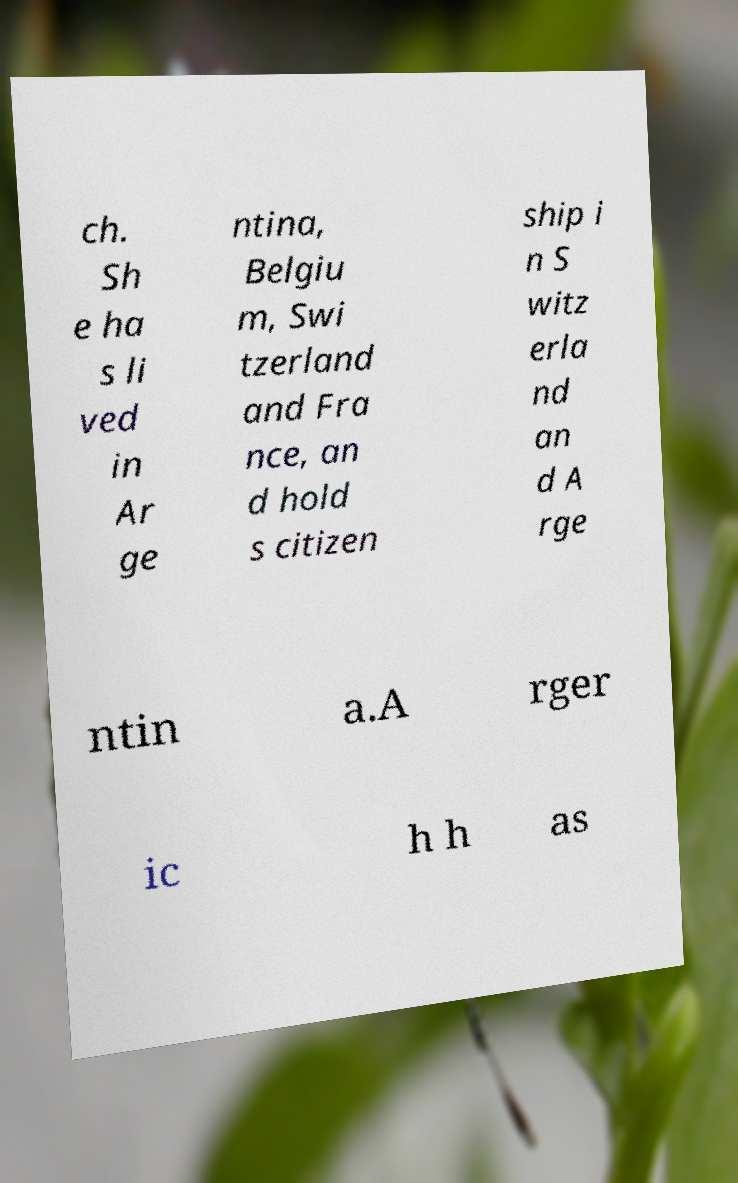For documentation purposes, I need the text within this image transcribed. Could you provide that? ch. Sh e ha s li ved in Ar ge ntina, Belgiu m, Swi tzerland and Fra nce, an d hold s citizen ship i n S witz erla nd an d A rge ntin a.A rger ic h h as 